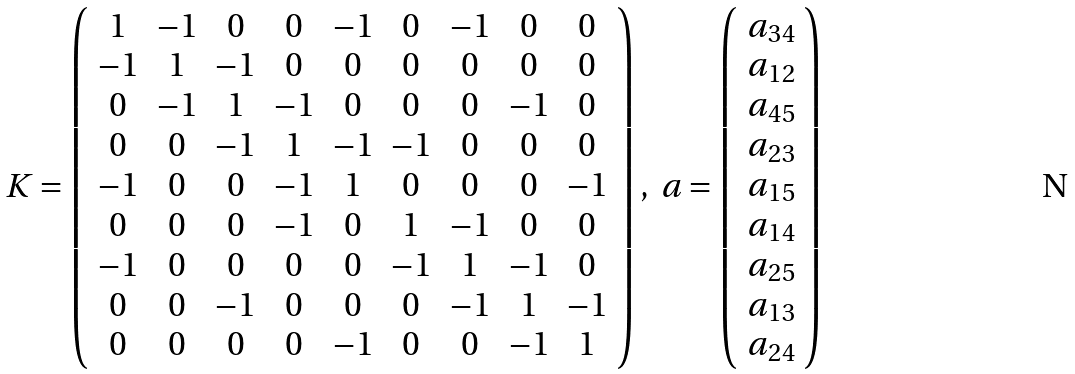<formula> <loc_0><loc_0><loc_500><loc_500>K = \left ( \begin{array} { c c c c c c c c c } 1 & - 1 & 0 & 0 & - 1 & 0 & - 1 & 0 & 0 \\ - 1 & 1 & - 1 & 0 & 0 & 0 & 0 & 0 & 0 \\ 0 & - 1 & 1 & - 1 & 0 & 0 & 0 & - 1 & 0 \\ 0 & 0 & - 1 & 1 & - 1 & - 1 & 0 & 0 & 0 \\ - 1 & 0 & 0 & - 1 & 1 & 0 & 0 & 0 & - 1 \\ 0 & 0 & 0 & - 1 & 0 & 1 & - 1 & 0 & 0 \\ - 1 & 0 & 0 & 0 & 0 & - 1 & 1 & - 1 & 0 \\ 0 & 0 & - 1 & 0 & 0 & 0 & - 1 & 1 & - 1 \\ 0 & 0 & 0 & 0 & - 1 & 0 & 0 & - 1 & 1 \end{array} \right ) , \ a = \left ( \begin{array} { c } a _ { 3 4 } \\ a _ { 1 2 } \\ a _ { 4 5 } \\ a _ { 2 3 } \\ a _ { 1 5 } \\ a _ { 1 4 } \\ a _ { 2 5 } \\ a _ { 1 3 } \\ a _ { 2 4 } \end{array} \right )</formula> 